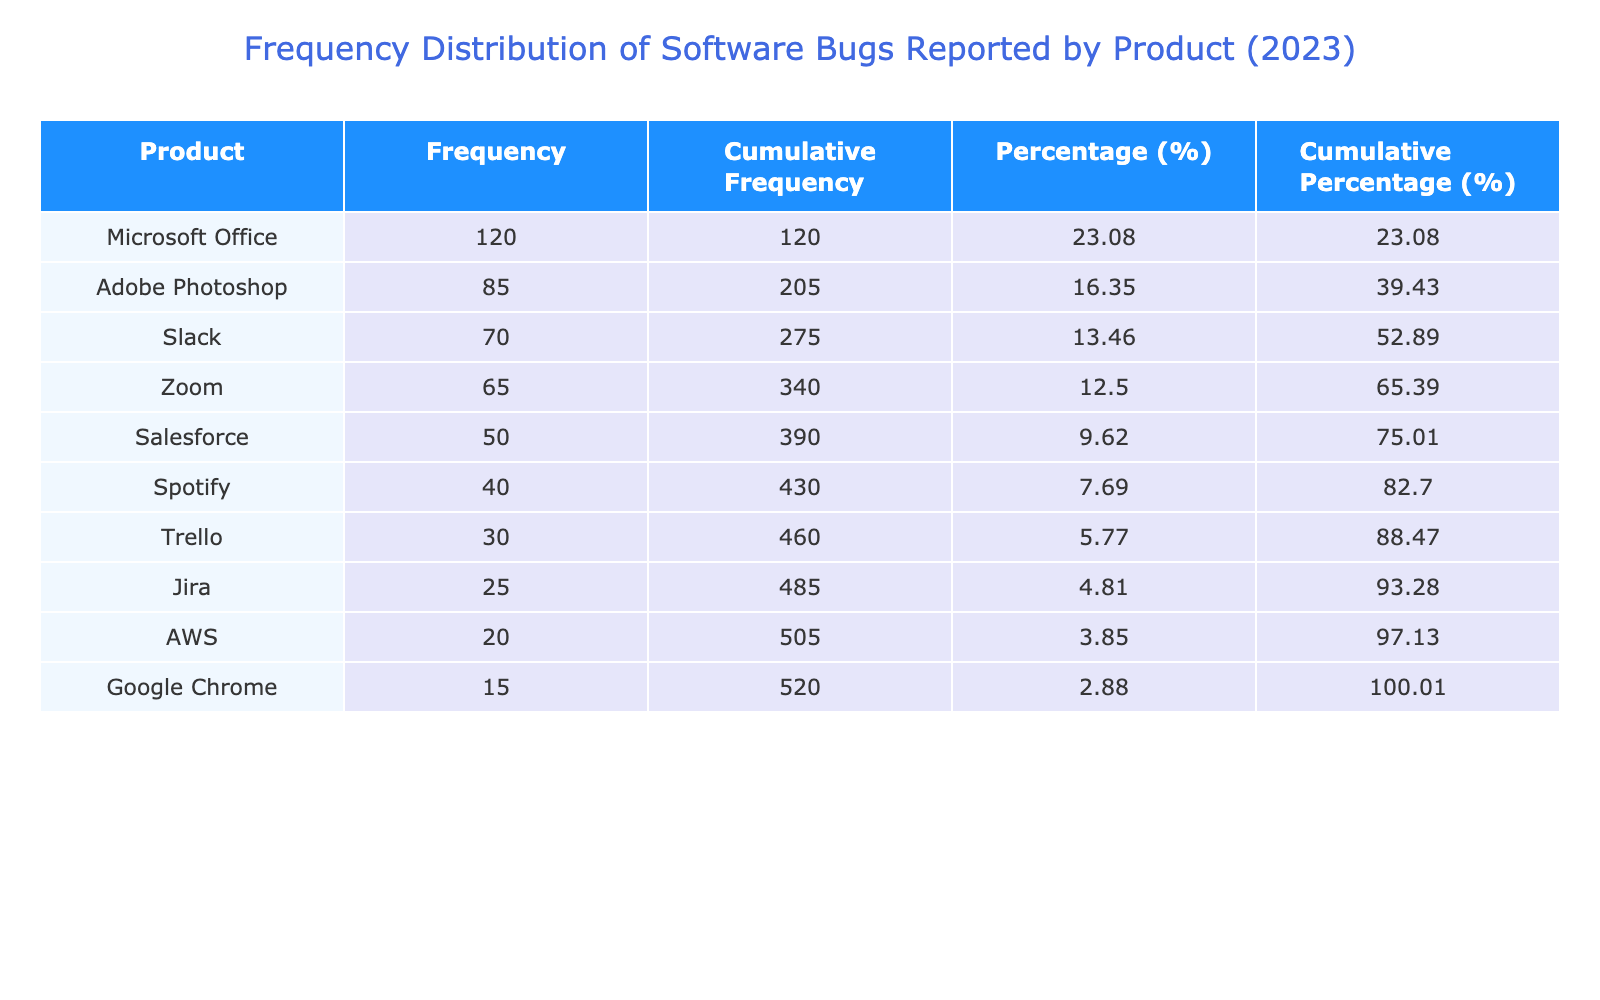What is the product with the highest frequency of bugs reported? By looking at the "Frequency of Bugs Reported" column in the table, we can see that "Microsoft Office" has the highest frequency at 120.
Answer: Microsoft Office How many bugs were reported for Adobe Photoshop? The table lists the frequency of bugs reported for Adobe Photoshop as 85.
Answer: 85 What is the cumulative frequency of bugs reported for Slack? To find the cumulative frequency for Slack, we look at the cumulative frequency column; Slack has a cumulative frequency of 265, which includes the frequencies of all products above it in the sorted list.
Answer: 265 Which product had a frequency of bugs reported that is less than 30? Checking the table, "Trello" (30) is not less than 30, but the next lowest is "Jira" with 25, which is indeed less than 30.
Answer: Jira What is the total frequency of bugs reported for the top three products? The top three products are "Microsoft Office" (120), "Adobe Photoshop" (85), and "Slack" (70). We sum these values: 120 + 85 + 70 = 275.
Answer: 275 Is the cumulative percentage for Google Chrome greater than 5%? We can calculate the percentage for Google Chrome, which is 15 total out of 600 total bugs, leading to a percentage of 2.5%. Additionally, we look at the cumulative percentage, which is also much lower than 5%. Hence, the answer is no.
Answer: No What is the difference in frequency between the product with the highest and lowest reported bugs? The highest frequency reported is 120 for Microsoft Office, and the lowest is 15 for Google Chrome. Therefore, the difference is 120 - 15 = 105.
Answer: 105 Which two products together reported more than 200 bugs? Adding the frequencies of Microsoft Office (120) and Adobe Photoshop (85), we get 120 + 85 = 205, which exceeds 200, making them a valid pair.
Answer: Microsoft Office and Adobe Photoshop What percentage of the total bugs reported were from Salesforce? The frequency for Salesforce is 50. The total is 600. The percentage is calculated by (50/600) * 100, resulting in approximately 8.33%.
Answer: 8.33% 